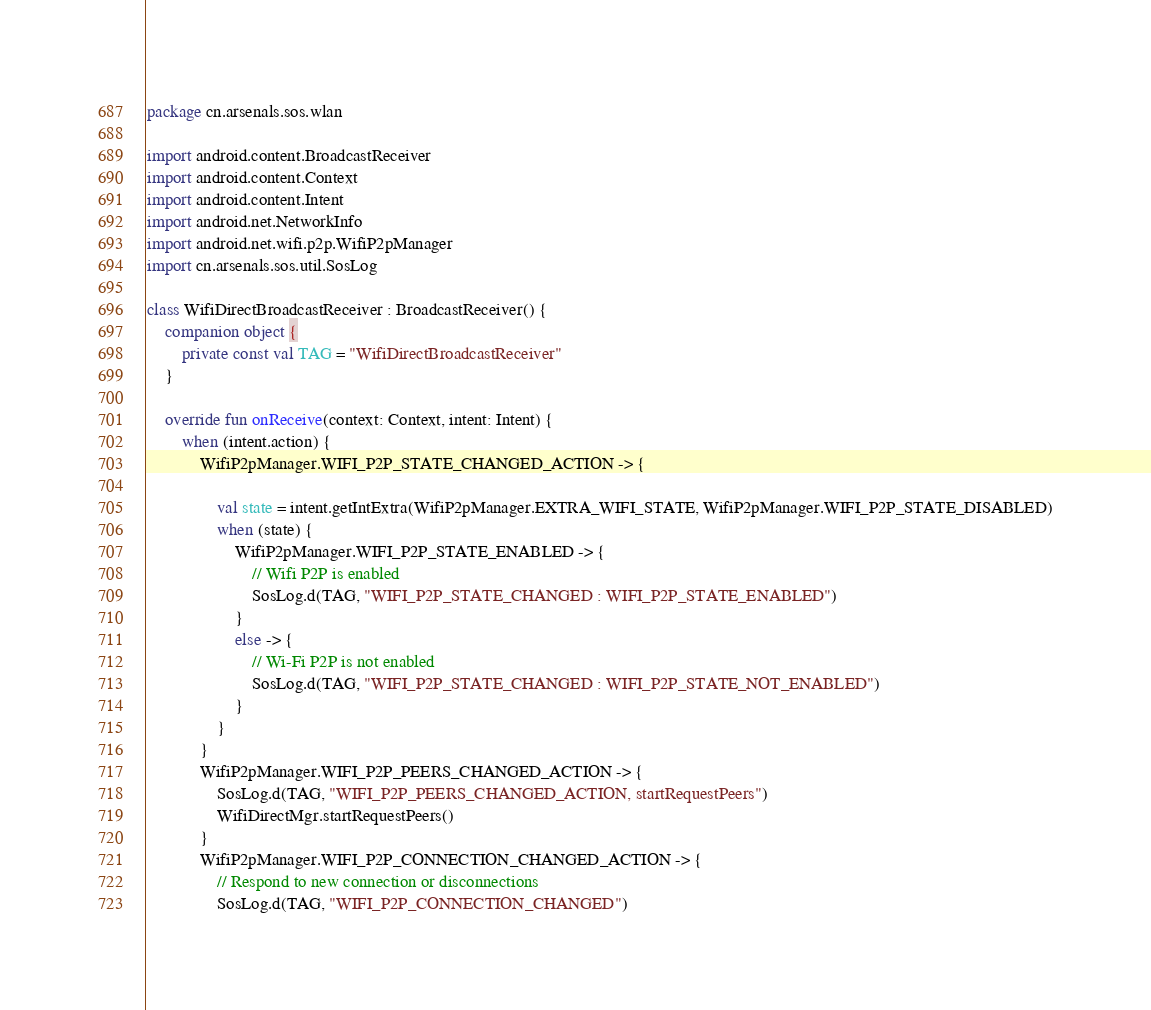<code> <loc_0><loc_0><loc_500><loc_500><_Kotlin_>package cn.arsenals.sos.wlan

import android.content.BroadcastReceiver
import android.content.Context
import android.content.Intent
import android.net.NetworkInfo
import android.net.wifi.p2p.WifiP2pManager
import cn.arsenals.sos.util.SosLog

class WifiDirectBroadcastReceiver : BroadcastReceiver() {
    companion object {
        private const val TAG = "WifiDirectBroadcastReceiver"
    }

    override fun onReceive(context: Context, intent: Intent) {
        when (intent.action) {
            WifiP2pManager.WIFI_P2P_STATE_CHANGED_ACTION -> {

                val state = intent.getIntExtra(WifiP2pManager.EXTRA_WIFI_STATE, WifiP2pManager.WIFI_P2P_STATE_DISABLED)
                when (state) {
                    WifiP2pManager.WIFI_P2P_STATE_ENABLED -> {
                        // Wifi P2P is enabled
                        SosLog.d(TAG, "WIFI_P2P_STATE_CHANGED : WIFI_P2P_STATE_ENABLED")
                    }
                    else -> {
                        // Wi-Fi P2P is not enabled
                        SosLog.d(TAG, "WIFI_P2P_STATE_CHANGED : WIFI_P2P_STATE_NOT_ENABLED")
                    }
                }
            }
            WifiP2pManager.WIFI_P2P_PEERS_CHANGED_ACTION -> {
                SosLog.d(TAG, "WIFI_P2P_PEERS_CHANGED_ACTION, startRequestPeers")
                WifiDirectMgr.startRequestPeers()
            }
            WifiP2pManager.WIFI_P2P_CONNECTION_CHANGED_ACTION -> {
                // Respond to new connection or disconnections
                SosLog.d(TAG, "WIFI_P2P_CONNECTION_CHANGED")</code> 